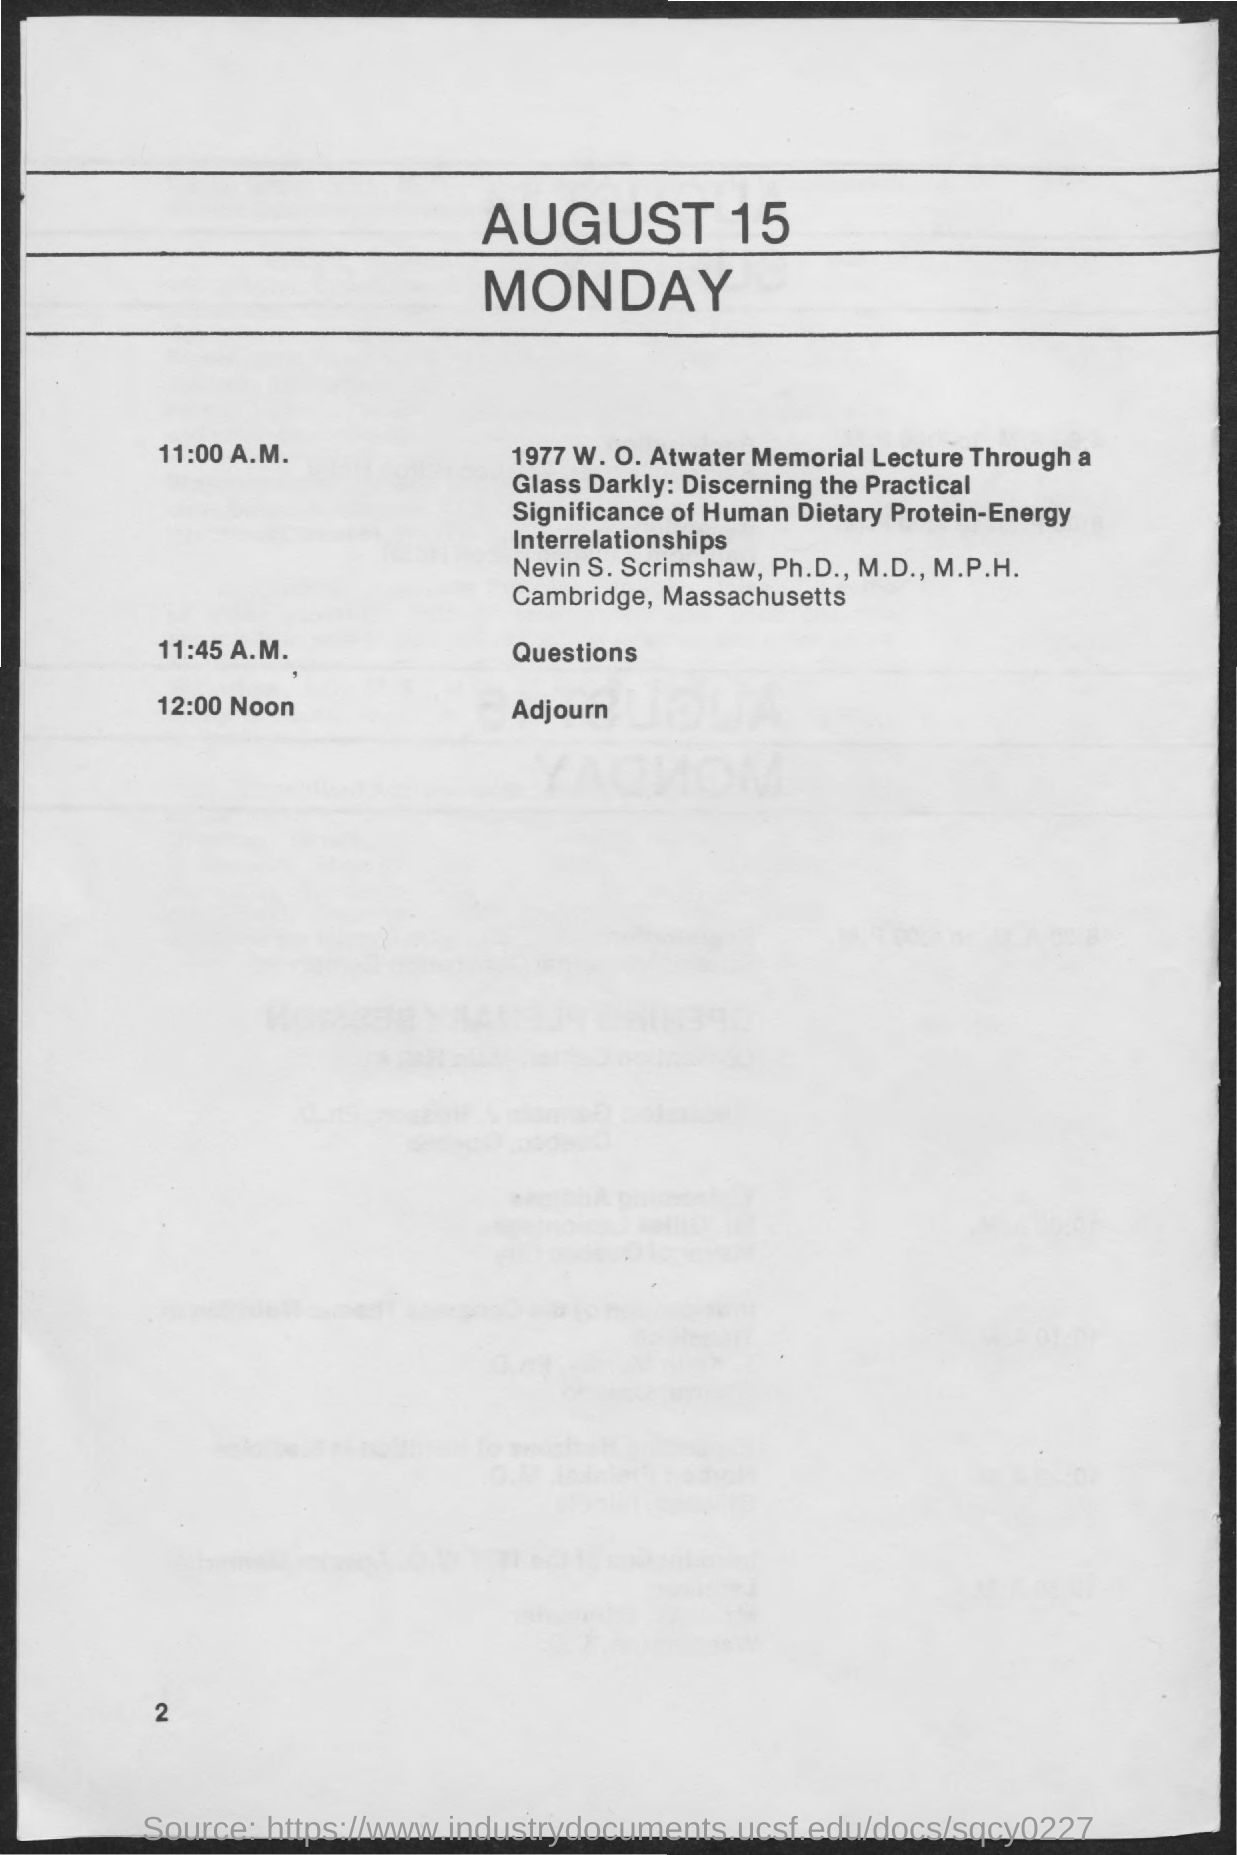List a handful of essential elements in this visual. The date on the document is August 15th. The adjournment time is 12:00 noon. 